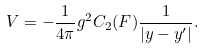Convert formula to latex. <formula><loc_0><loc_0><loc_500><loc_500>V = - \frac { 1 } { 4 \pi } g ^ { 2 } C _ { 2 } ( F ) \frac { 1 } { { | { y } - { y ^ { \prime } } | } } .</formula> 